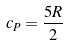Convert formula to latex. <formula><loc_0><loc_0><loc_500><loc_500>c _ { P } = \frac { 5 R } { 2 }</formula> 